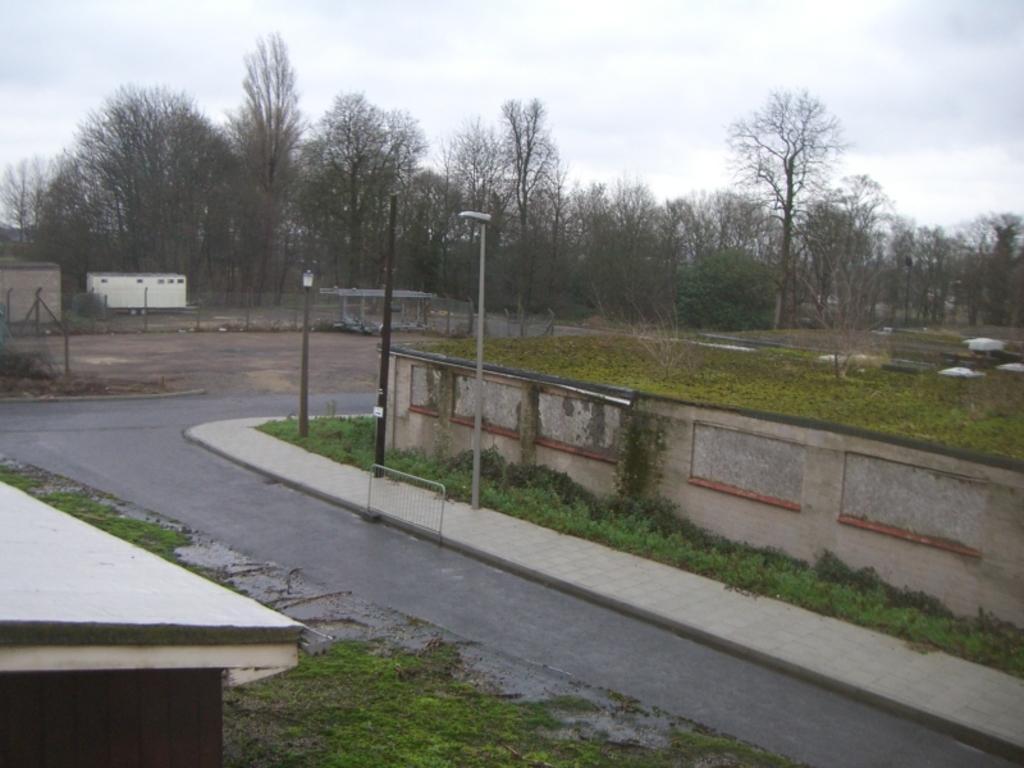Can you describe this image briefly? In this picture we can see a barrier, poles, wall, plants and grass. On the left side of the image, those are looking like houses and the fence. Behind the fence there are trees and the cloudy sky. 